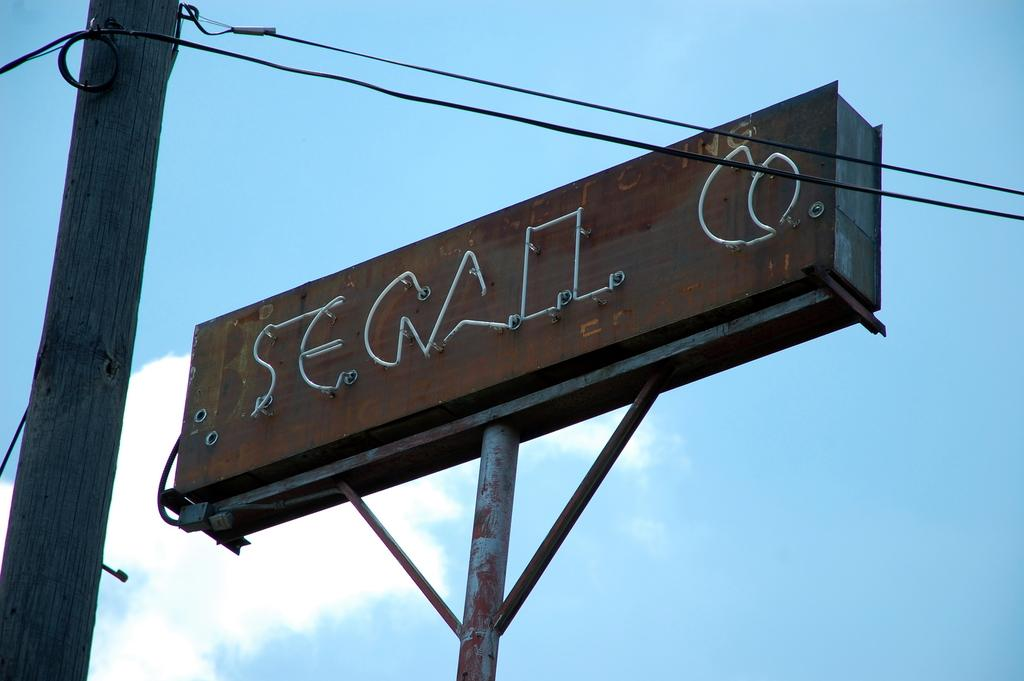What is the main structure in the image? There is a pole in the image with a board attached to it. What else can be seen near the pole? There is a wooden trunk with wires attached to it in the image. What is visible in the background of the image? The sky is visible in the background of the image, and there are clouds in the sky. What type of holiday is being celebrated in the image? There is no indication of a holiday being celebrated in the image. Can you see any animals from the zoo in the image? There are no animals from a zoo present in the image. 